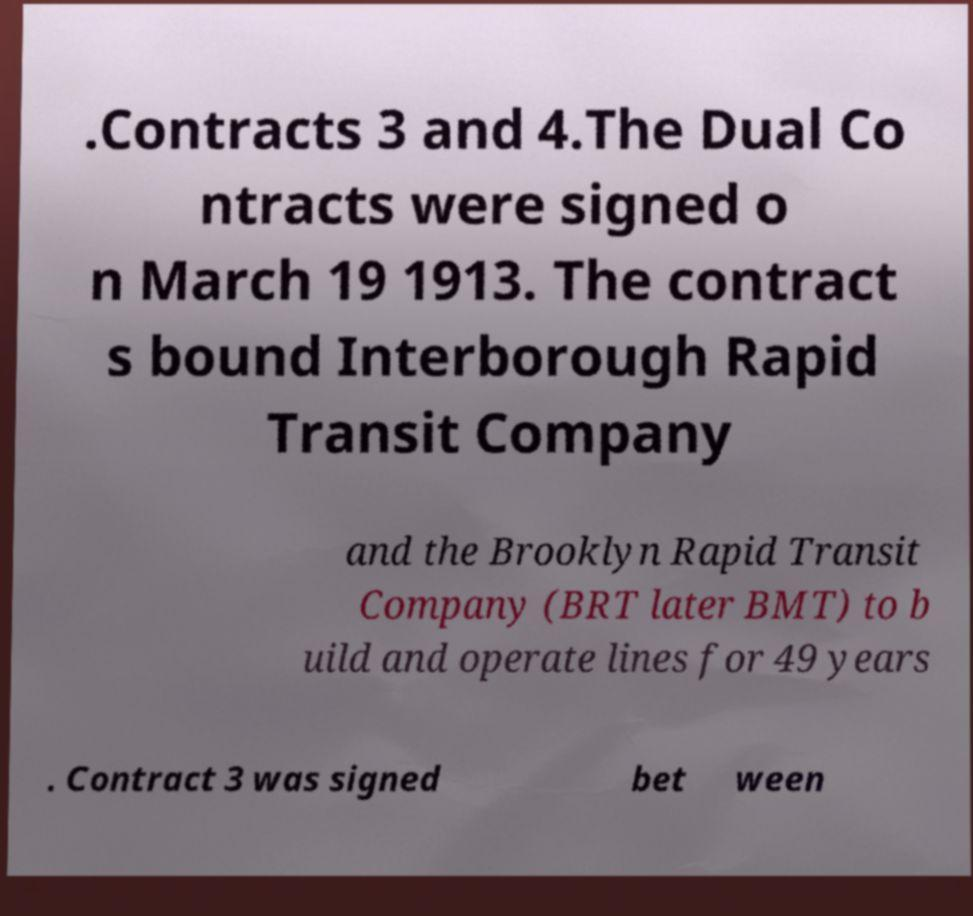Could you assist in decoding the text presented in this image and type it out clearly? .Contracts 3 and 4.The Dual Co ntracts were signed o n March 19 1913. The contract s bound Interborough Rapid Transit Company and the Brooklyn Rapid Transit Company (BRT later BMT) to b uild and operate lines for 49 years . Contract 3 was signed bet ween 